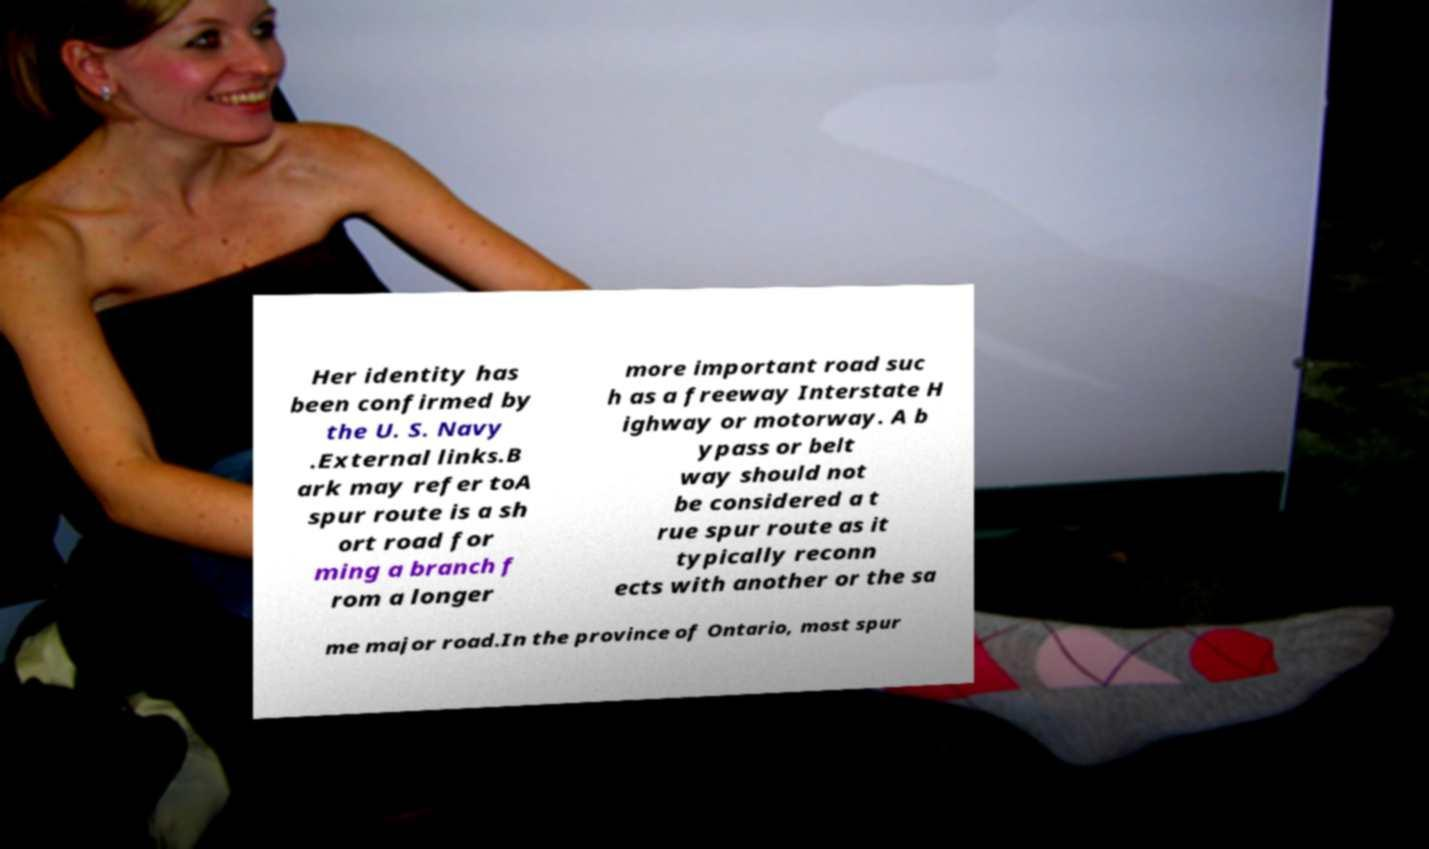I need the written content from this picture converted into text. Can you do that? Her identity has been confirmed by the U. S. Navy .External links.B ark may refer toA spur route is a sh ort road for ming a branch f rom a longer more important road suc h as a freeway Interstate H ighway or motorway. A b ypass or belt way should not be considered a t rue spur route as it typically reconn ects with another or the sa me major road.In the province of Ontario, most spur 